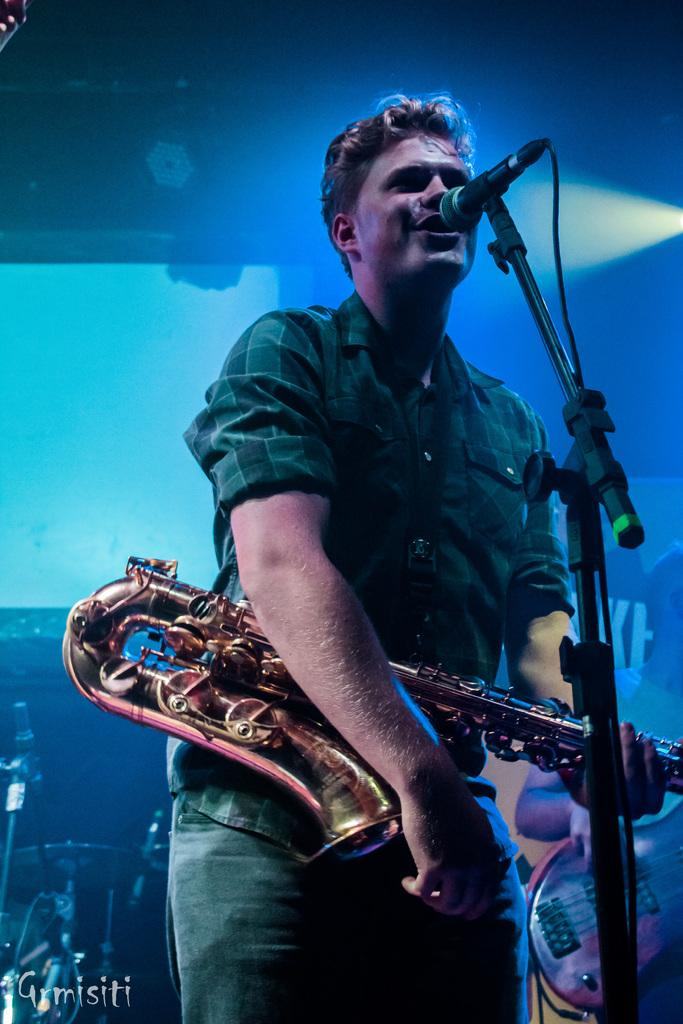What is the man in the image doing? The man is singing into a microphone. How is the man dressed in the image? The man is wearing a shirt and trousers. What instrument is the man holding in the image? The man is holding a trumpet in his hands. Is there any text or marking at the bottom of the image? Yes, there is a watermark at the bottom of the image. How does the man's throat feel while singing in the image? There is no information about the man's throat or how he feels while singing in the image. --- Facts: 1. There is a car in the image. 2. The car is red. 3. The car has four wheels. 4. There is a person sitting in the driver's seat. 5. The car is parked on the side of the road. Absurd Topics: bird, ocean, mountain Conversation: What is the color of the car in the image? The car is red. How many wheels does the car have? The car has four wheels. Who is inside the car in the image? There is a person sitting in the driver's seat. Where is the car located in the image? The car is parked on the side of the road. Reasoning: Let's think step by step in order to produce the conversation. We start by identifying the main subject in the image, which is the car. Then, we describe the car's color, which is red. Next, we mention the number of wheels the car has, which is four. We also note the presence of a person sitting in the driver's seat. Finally, we acknowledge the car's location, which is parked on the side of the road. Absurd Question/Answer: Can you see any birds flying over the car in the image? There is no information about birds in the image. 